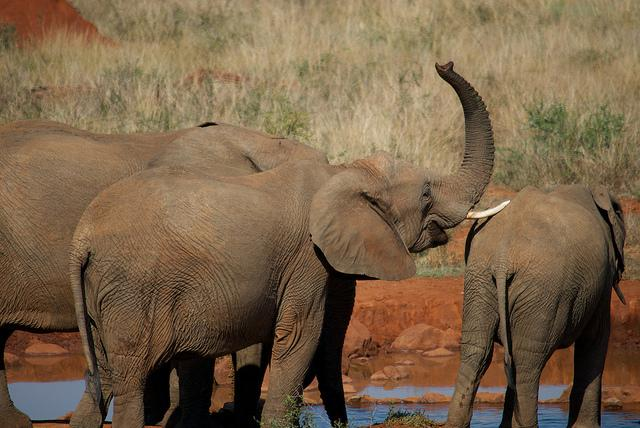What is not unique about this animals? Please explain your reasoning. four legs. Many mammals have four legs and the rest of the items on the list are not as common. 